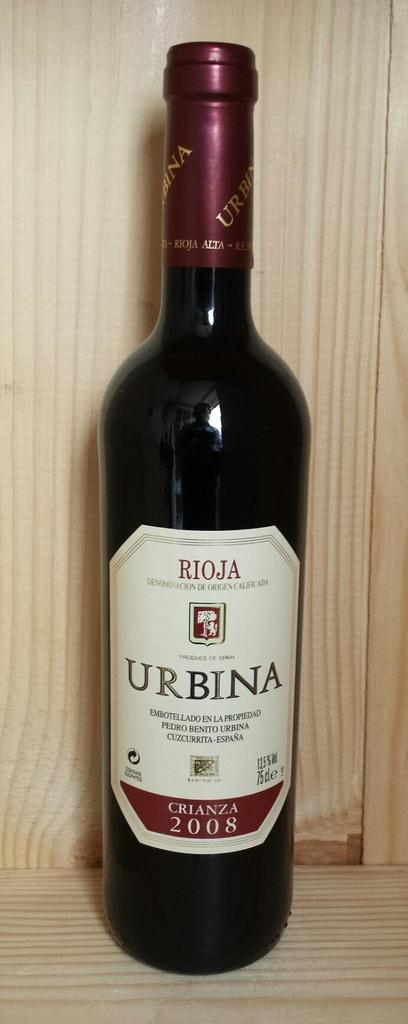<image>
Describe the image concisely. A bottle of Rioja Urbina is on the wooden ledge. 